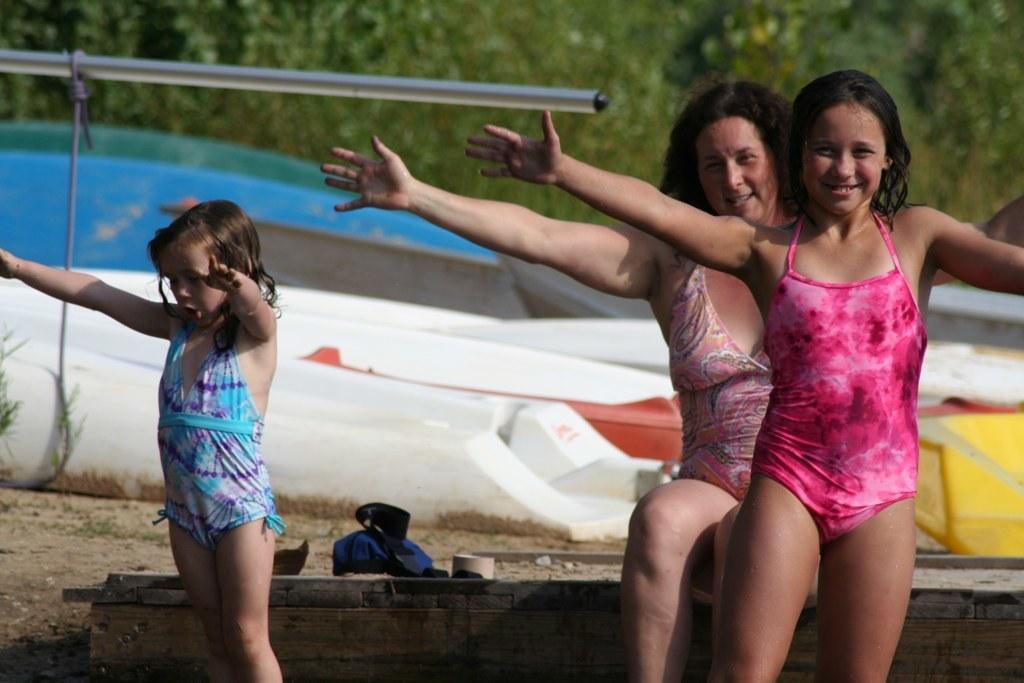Please provide a concise description of this image. This picture might be taken on sea shore. In this image, on the right side, we can see a woman sitting on the bench and a girl is standing. On the left side, we can also see a girl standing on the land. In the background, we can see a boat, trees. At the bottom, we can see a land with some stones. 